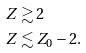<formula> <loc_0><loc_0><loc_500><loc_500>Z & \gtrsim 2 \\ Z & \lesssim Z _ { 0 } - 2 .</formula> 